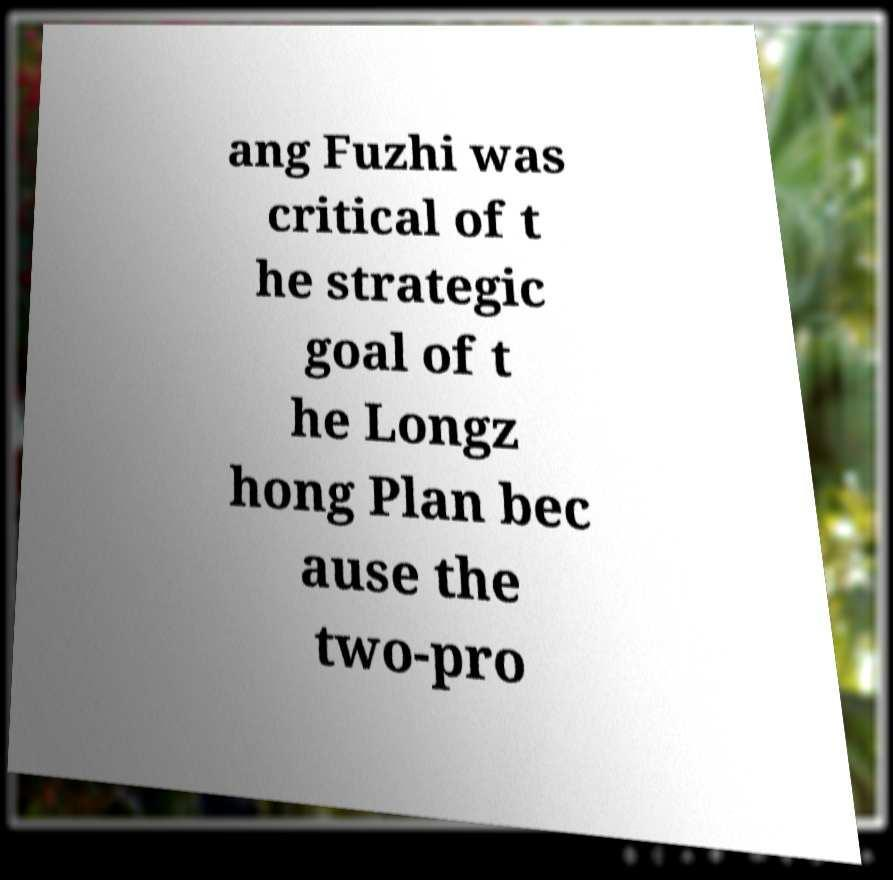There's text embedded in this image that I need extracted. Can you transcribe it verbatim? ang Fuzhi was critical of t he strategic goal of t he Longz hong Plan bec ause the two-pro 